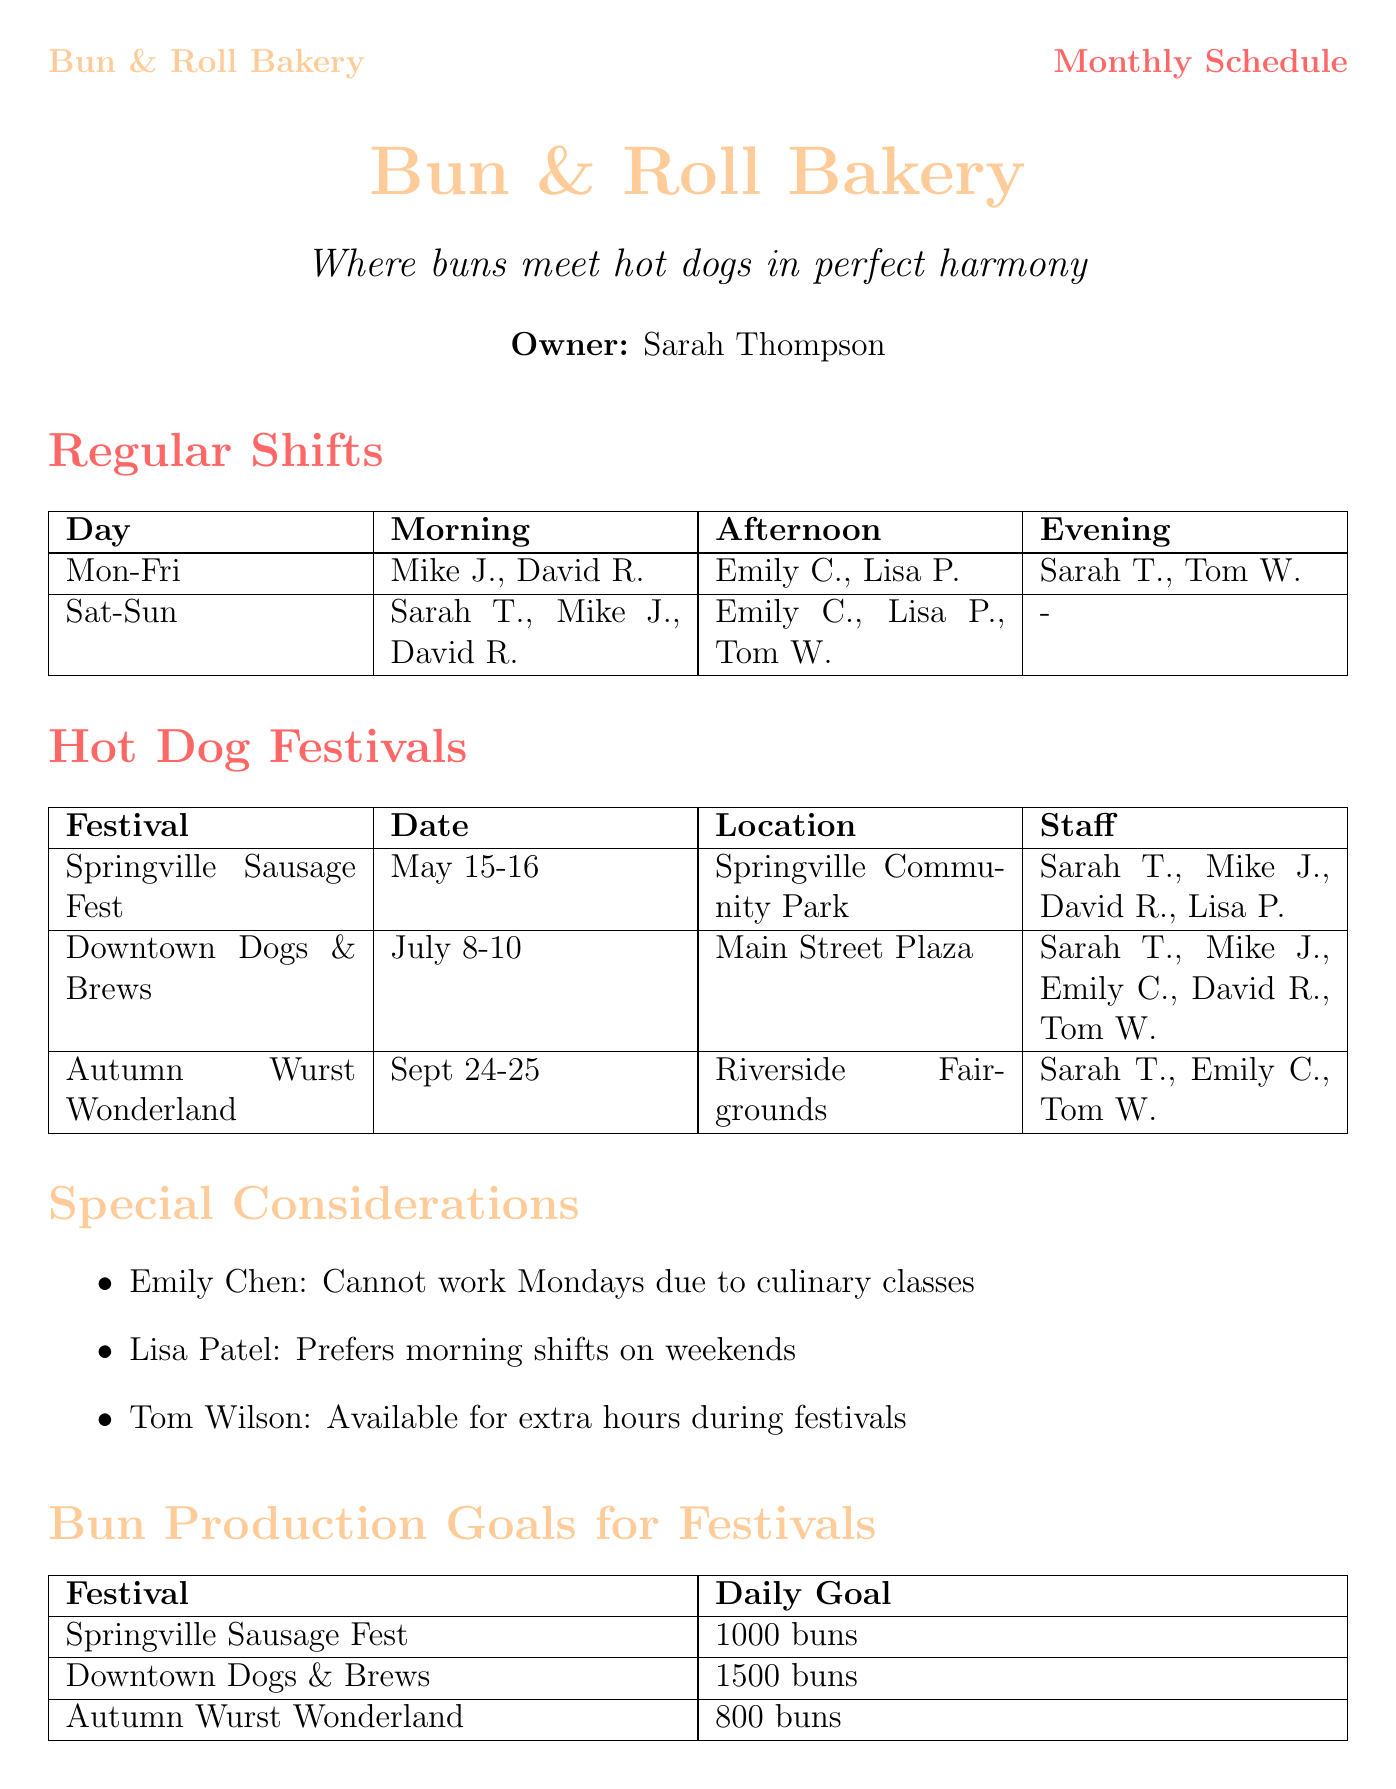What is the bakery's name? The bakery's name is stated clearly at the top of the document.
Answer: Bun & Roll Bakery Who is the head baker? The head baker is listed in the employee section.
Answer: Mike Johnson When is the Springville Sausage Fest? The date of the festival is provided in the festival table.
Answer: May 15-16 How many staff are needed for the Downtown Dogs & Brews festival? The staff needed for each festival is specified in the document.
Answer: 5 Which employee cannot work Mondays? The special considerations note which employee has restrictions.
Answer: Emily Chen What is the daily bun production goal for the Downtown Dogs & Brews festival? The bun production goals are outlined in the corresponding section.
Answer: 1500 buns Which employee prefers morning shifts on weekends? The special considerations list includes preferences of employees.
Answer: Lisa Patel What position does Tom Wilson hold? The position of each employee is specified in the employee section.
Answer: Delivery Driver Which festival is scheduled in September? The month of each festival is mentioned in the festival table.
Answer: Autumn Wurst Wonderland 